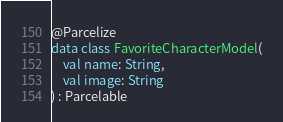Convert code to text. <code><loc_0><loc_0><loc_500><loc_500><_Kotlin_>@Parcelize
data class FavoriteCharacterModel(
    val name: String,
    val image: String
) : Parcelable</code> 